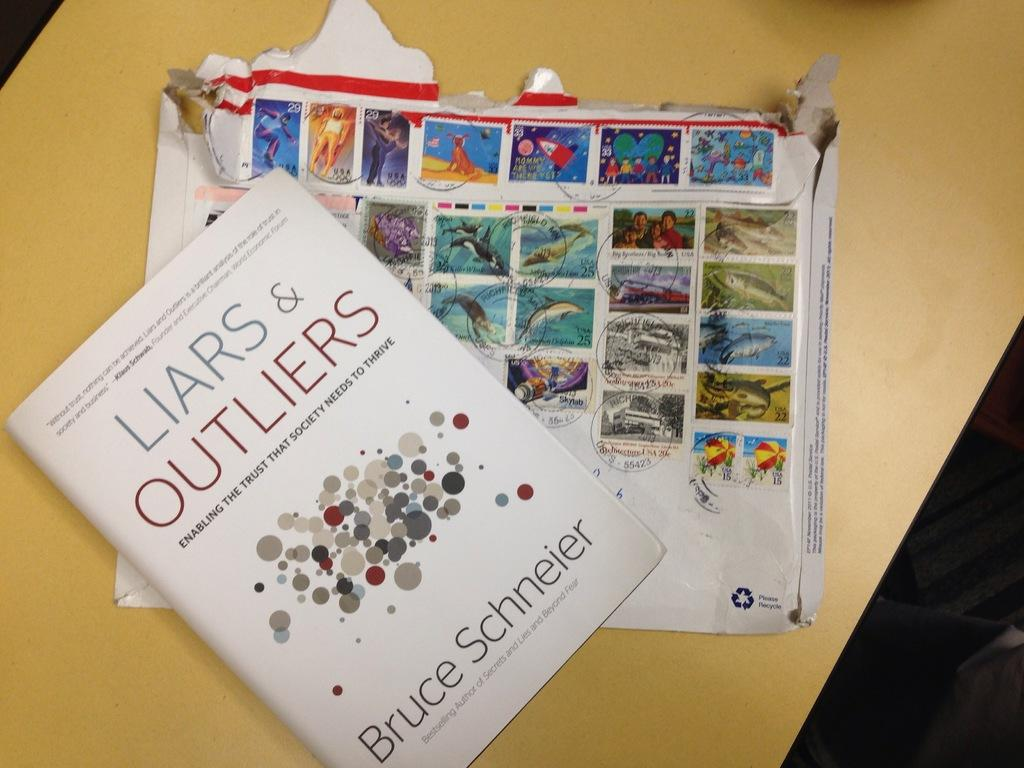<image>
Share a concise interpretation of the image provided. A book, entitled Liars & Outliers rests upon a display of cancelled postage stamps. 